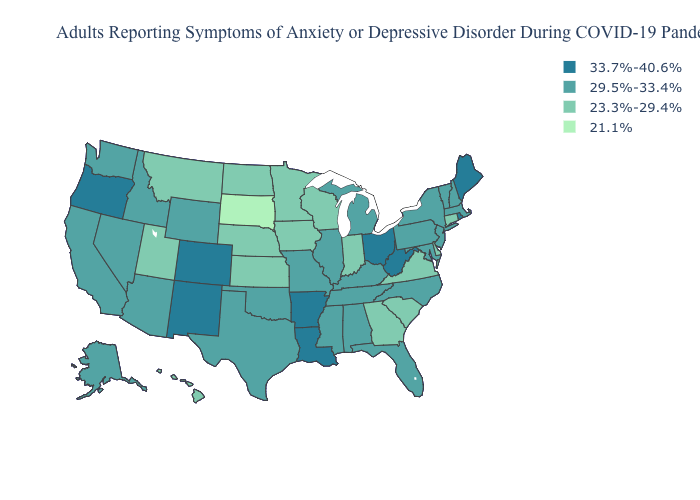How many symbols are there in the legend?
Give a very brief answer. 4. Which states hav the highest value in the West?
Write a very short answer. Colorado, New Mexico, Oregon. Does West Virginia have a higher value than Maine?
Answer briefly. No. What is the lowest value in states that border Maine?
Write a very short answer. 29.5%-33.4%. Among the states that border Arkansas , does Louisiana have the lowest value?
Short answer required. No. What is the value of Iowa?
Give a very brief answer. 23.3%-29.4%. What is the lowest value in states that border Illinois?
Keep it brief. 23.3%-29.4%. Which states have the lowest value in the USA?
Be succinct. South Dakota. Does New Mexico have the highest value in the West?
Answer briefly. Yes. Name the states that have a value in the range 29.5%-33.4%?
Concise answer only. Alabama, Alaska, Arizona, California, Florida, Idaho, Illinois, Kentucky, Maryland, Massachusetts, Michigan, Mississippi, Missouri, Nevada, New Hampshire, New Jersey, New York, North Carolina, Oklahoma, Pennsylvania, Tennessee, Texas, Vermont, Washington, Wyoming. Does Iowa have the highest value in the MidWest?
Keep it brief. No. Name the states that have a value in the range 21.1%?
Write a very short answer. South Dakota. What is the value of Michigan?
Be succinct. 29.5%-33.4%. Which states have the highest value in the USA?
Write a very short answer. Arkansas, Colorado, Louisiana, Maine, New Mexico, Ohio, Oregon, Rhode Island, West Virginia. What is the lowest value in the USA?
Answer briefly. 21.1%. 